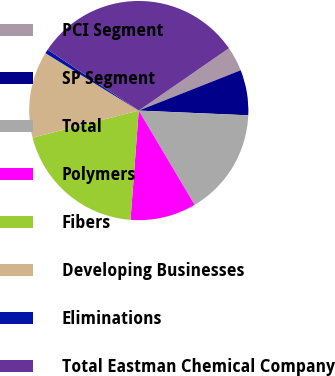Convert chart. <chart><loc_0><loc_0><loc_500><loc_500><pie_chart><fcel>PCI Segment<fcel>SP Segment<fcel>Total<fcel>Polymers<fcel>Fibers<fcel>Developing Businesses<fcel>Eliminations<fcel>Total Eastman Chemical Company<nl><fcel>3.64%<fcel>6.68%<fcel>15.8%<fcel>9.72%<fcel>19.82%<fcel>12.76%<fcel>0.6%<fcel>31.0%<nl></chart> 